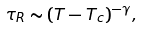Convert formula to latex. <formula><loc_0><loc_0><loc_500><loc_500>\tau _ { R } \sim ( T - T _ { c } ) ^ { - \gamma } ,</formula> 